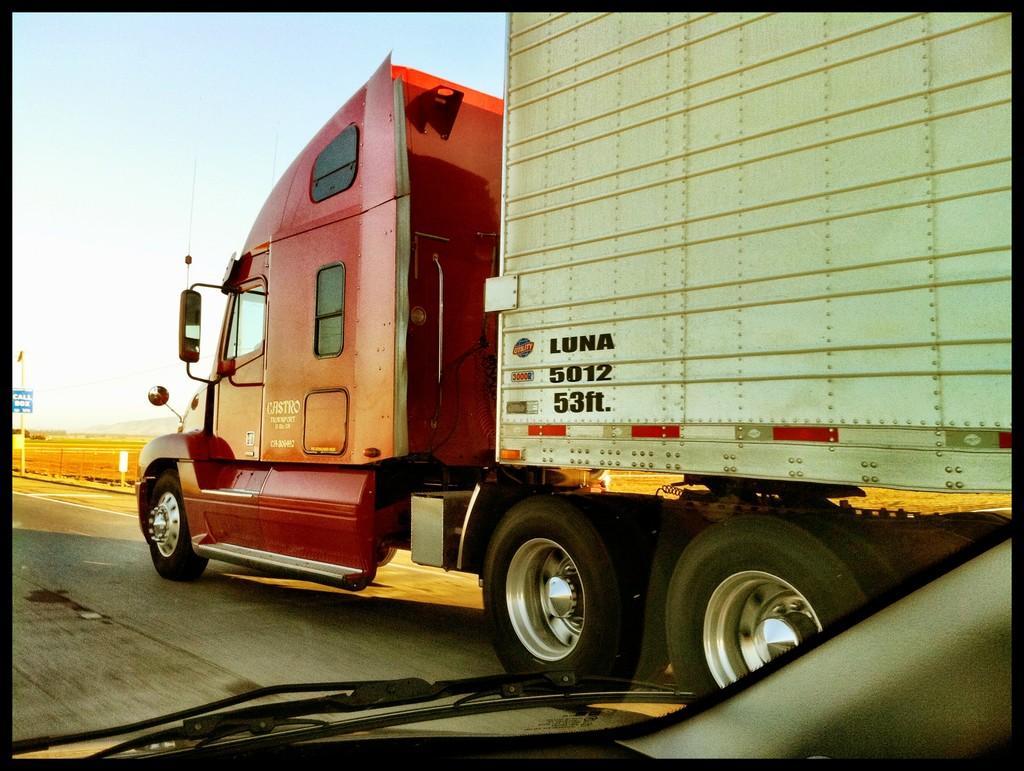Could you give a brief overview of what you see in this image? This is a picture and here we can see vehicles on the road and in the background, there are poles and we can see a fence. At the top, there is sky. 